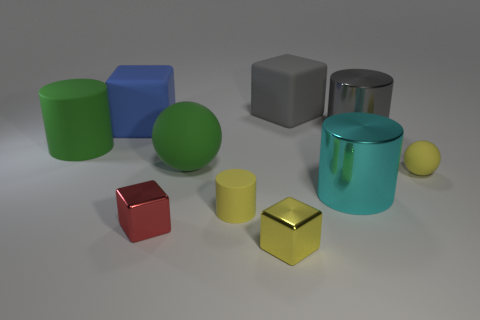What material is the tiny yellow ball?
Offer a terse response. Rubber. What is the big thing that is both behind the green cylinder and on the left side of the small red thing made of?
Offer a very short reply. Rubber. Does the tiny ball have the same color as the rubber cylinder behind the cyan metallic cylinder?
Your answer should be very brief. No. There is a sphere that is the same size as the blue object; what is its material?
Your answer should be compact. Rubber. Are there any red cubes made of the same material as the yellow cube?
Provide a short and direct response. Yes. How many matte spheres are there?
Ensure brevity in your answer.  2. Is the gray cylinder made of the same material as the big cylinder that is left of the big green ball?
Your answer should be compact. No. There is a thing that is the same color as the large rubber cylinder; what material is it?
Offer a terse response. Rubber. What number of large cylinders are the same color as the large rubber ball?
Make the answer very short. 1. The gray matte object is what size?
Ensure brevity in your answer.  Large. 